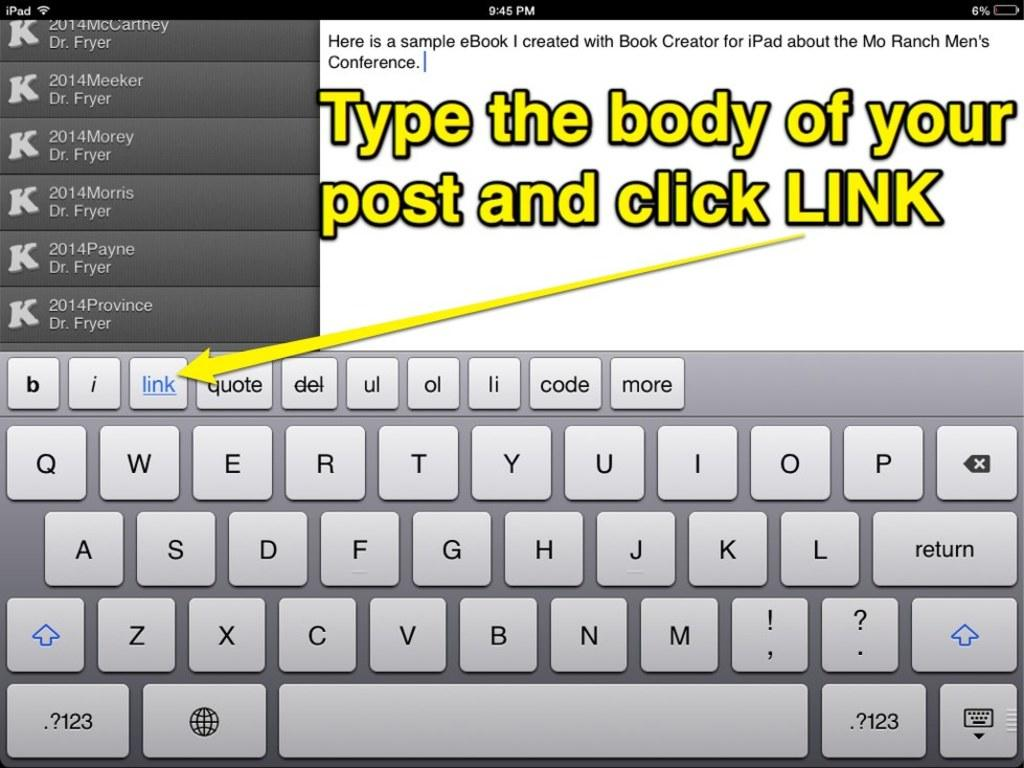Provide a one-sentence caption for the provided image. Yellow text explains where to click the link. 